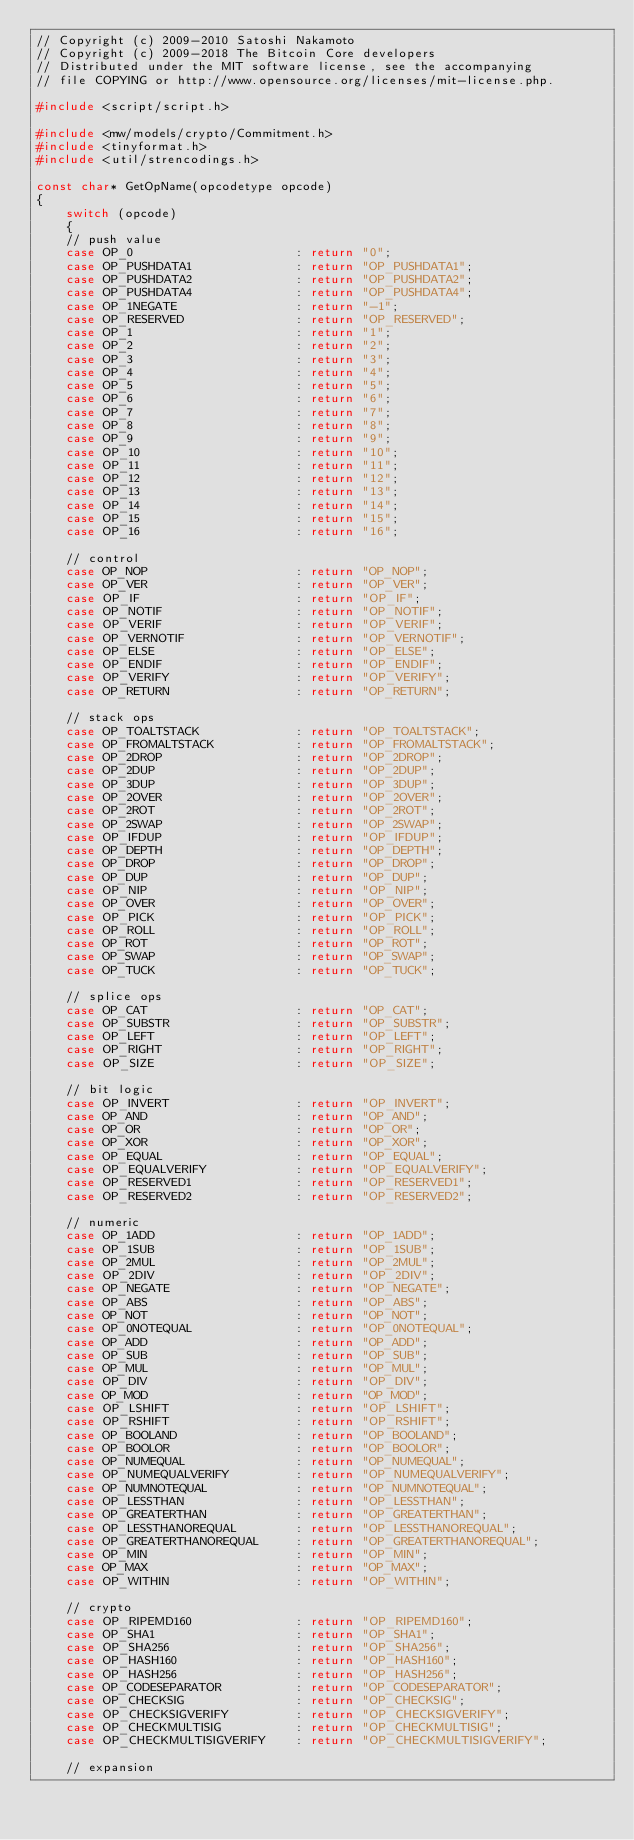Convert code to text. <code><loc_0><loc_0><loc_500><loc_500><_C++_>// Copyright (c) 2009-2010 Satoshi Nakamoto
// Copyright (c) 2009-2018 The Bitcoin Core developers
// Distributed under the MIT software license, see the accompanying
// file COPYING or http://www.opensource.org/licenses/mit-license.php.

#include <script/script.h>

#include <mw/models/crypto/Commitment.h>
#include <tinyformat.h>
#include <util/strencodings.h>

const char* GetOpName(opcodetype opcode)
{
    switch (opcode)
    {
    // push value
    case OP_0                      : return "0";
    case OP_PUSHDATA1              : return "OP_PUSHDATA1";
    case OP_PUSHDATA2              : return "OP_PUSHDATA2";
    case OP_PUSHDATA4              : return "OP_PUSHDATA4";
    case OP_1NEGATE                : return "-1";
    case OP_RESERVED               : return "OP_RESERVED";
    case OP_1                      : return "1";
    case OP_2                      : return "2";
    case OP_3                      : return "3";
    case OP_4                      : return "4";
    case OP_5                      : return "5";
    case OP_6                      : return "6";
    case OP_7                      : return "7";
    case OP_8                      : return "8";
    case OP_9                      : return "9";
    case OP_10                     : return "10";
    case OP_11                     : return "11";
    case OP_12                     : return "12";
    case OP_13                     : return "13";
    case OP_14                     : return "14";
    case OP_15                     : return "15";
    case OP_16                     : return "16";

    // control
    case OP_NOP                    : return "OP_NOP";
    case OP_VER                    : return "OP_VER";
    case OP_IF                     : return "OP_IF";
    case OP_NOTIF                  : return "OP_NOTIF";
    case OP_VERIF                  : return "OP_VERIF";
    case OP_VERNOTIF               : return "OP_VERNOTIF";
    case OP_ELSE                   : return "OP_ELSE";
    case OP_ENDIF                  : return "OP_ENDIF";
    case OP_VERIFY                 : return "OP_VERIFY";
    case OP_RETURN                 : return "OP_RETURN";

    // stack ops
    case OP_TOALTSTACK             : return "OP_TOALTSTACK";
    case OP_FROMALTSTACK           : return "OP_FROMALTSTACK";
    case OP_2DROP                  : return "OP_2DROP";
    case OP_2DUP                   : return "OP_2DUP";
    case OP_3DUP                   : return "OP_3DUP";
    case OP_2OVER                  : return "OP_2OVER";
    case OP_2ROT                   : return "OP_2ROT";
    case OP_2SWAP                  : return "OP_2SWAP";
    case OP_IFDUP                  : return "OP_IFDUP";
    case OP_DEPTH                  : return "OP_DEPTH";
    case OP_DROP                   : return "OP_DROP";
    case OP_DUP                    : return "OP_DUP";
    case OP_NIP                    : return "OP_NIP";
    case OP_OVER                   : return "OP_OVER";
    case OP_PICK                   : return "OP_PICK";
    case OP_ROLL                   : return "OP_ROLL";
    case OP_ROT                    : return "OP_ROT";
    case OP_SWAP                   : return "OP_SWAP";
    case OP_TUCK                   : return "OP_TUCK";

    // splice ops
    case OP_CAT                    : return "OP_CAT";
    case OP_SUBSTR                 : return "OP_SUBSTR";
    case OP_LEFT                   : return "OP_LEFT";
    case OP_RIGHT                  : return "OP_RIGHT";
    case OP_SIZE                   : return "OP_SIZE";

    // bit logic
    case OP_INVERT                 : return "OP_INVERT";
    case OP_AND                    : return "OP_AND";
    case OP_OR                     : return "OP_OR";
    case OP_XOR                    : return "OP_XOR";
    case OP_EQUAL                  : return "OP_EQUAL";
    case OP_EQUALVERIFY            : return "OP_EQUALVERIFY";
    case OP_RESERVED1              : return "OP_RESERVED1";
    case OP_RESERVED2              : return "OP_RESERVED2";

    // numeric
    case OP_1ADD                   : return "OP_1ADD";
    case OP_1SUB                   : return "OP_1SUB";
    case OP_2MUL                   : return "OP_2MUL";
    case OP_2DIV                   : return "OP_2DIV";
    case OP_NEGATE                 : return "OP_NEGATE";
    case OP_ABS                    : return "OP_ABS";
    case OP_NOT                    : return "OP_NOT";
    case OP_0NOTEQUAL              : return "OP_0NOTEQUAL";
    case OP_ADD                    : return "OP_ADD";
    case OP_SUB                    : return "OP_SUB";
    case OP_MUL                    : return "OP_MUL";
    case OP_DIV                    : return "OP_DIV";
    case OP_MOD                    : return "OP_MOD";
    case OP_LSHIFT                 : return "OP_LSHIFT";
    case OP_RSHIFT                 : return "OP_RSHIFT";
    case OP_BOOLAND                : return "OP_BOOLAND";
    case OP_BOOLOR                 : return "OP_BOOLOR";
    case OP_NUMEQUAL               : return "OP_NUMEQUAL";
    case OP_NUMEQUALVERIFY         : return "OP_NUMEQUALVERIFY";
    case OP_NUMNOTEQUAL            : return "OP_NUMNOTEQUAL";
    case OP_LESSTHAN               : return "OP_LESSTHAN";
    case OP_GREATERTHAN            : return "OP_GREATERTHAN";
    case OP_LESSTHANOREQUAL        : return "OP_LESSTHANOREQUAL";
    case OP_GREATERTHANOREQUAL     : return "OP_GREATERTHANOREQUAL";
    case OP_MIN                    : return "OP_MIN";
    case OP_MAX                    : return "OP_MAX";
    case OP_WITHIN                 : return "OP_WITHIN";

    // crypto
    case OP_RIPEMD160              : return "OP_RIPEMD160";
    case OP_SHA1                   : return "OP_SHA1";
    case OP_SHA256                 : return "OP_SHA256";
    case OP_HASH160                : return "OP_HASH160";
    case OP_HASH256                : return "OP_HASH256";
    case OP_CODESEPARATOR          : return "OP_CODESEPARATOR";
    case OP_CHECKSIG               : return "OP_CHECKSIG";
    case OP_CHECKSIGVERIFY         : return "OP_CHECKSIGVERIFY";
    case OP_CHECKMULTISIG          : return "OP_CHECKMULTISIG";
    case OP_CHECKMULTISIGVERIFY    : return "OP_CHECKMULTISIGVERIFY";

    // expansion</code> 